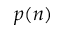<formula> <loc_0><loc_0><loc_500><loc_500>p ( n )</formula> 